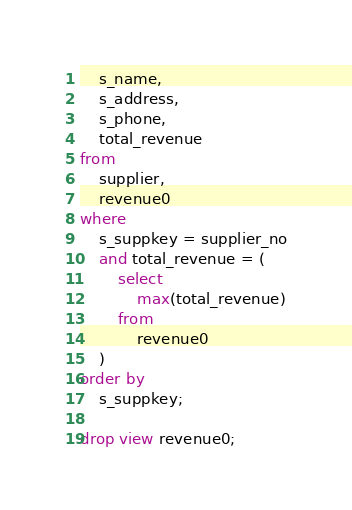Convert code to text. <code><loc_0><loc_0><loc_500><loc_500><_SQL_>    s_name,
    s_address,
    s_phone,
    total_revenue
from
    supplier,
    revenue0
where
    s_suppkey = supplier_no
    and total_revenue = (
        select
            max(total_revenue)
        from
            revenue0
    )
order by
    s_suppkey;

drop view revenue0;
</code> 